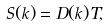Convert formula to latex. <formula><loc_0><loc_0><loc_500><loc_500>S ( k ) = D ( k ) T ,</formula> 